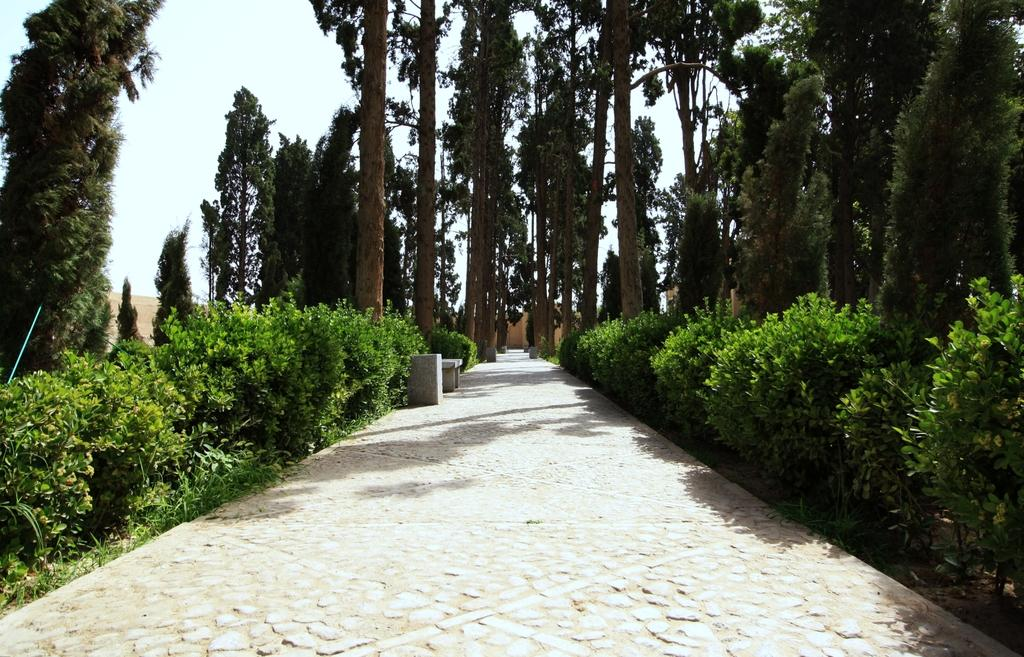What is the main feature of the image? There is a road in the image. What can be seen near the road? There are many plants and trees near the road. What is the color of the plants and trees? The plants and trees are green in color. What is visible in the background of the image? The sky is visible in the background of the image. Where are the babies playing on the floor in the image? There are no babies or floor present in the image; it features a road with plants and trees near it. 